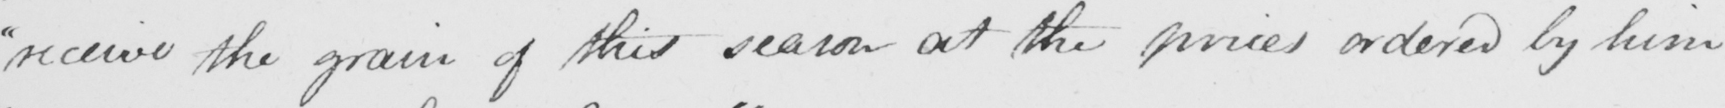What text is written in this handwritten line? " receive the grain of this season at the prices ordered by him 